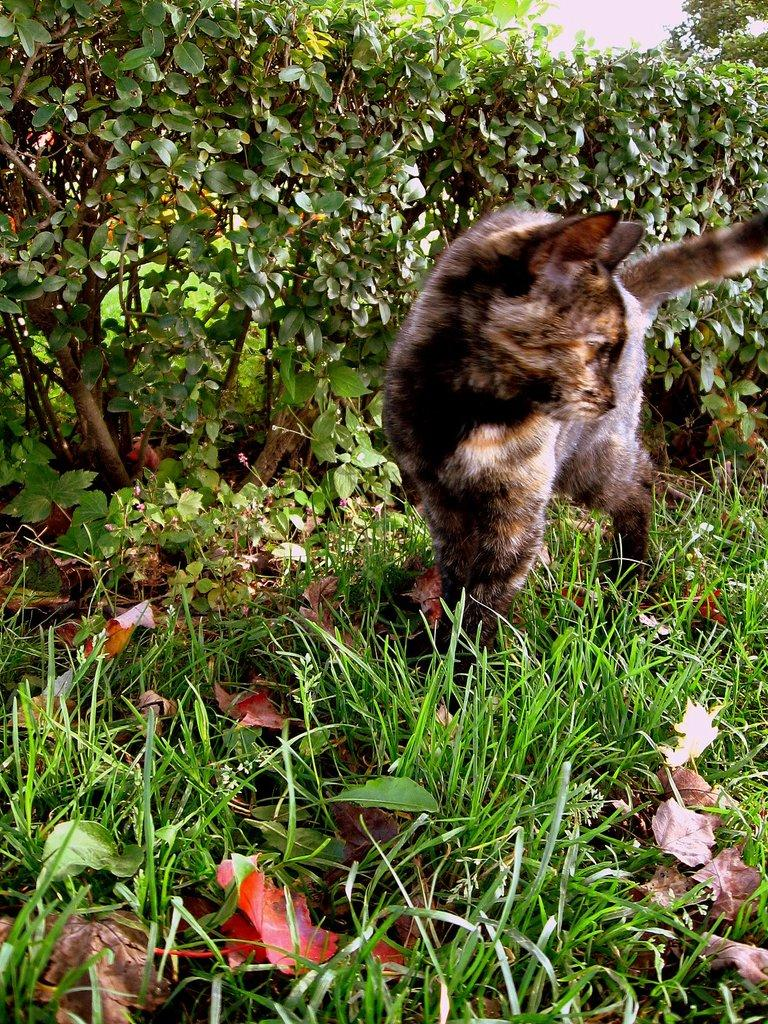Where was the picture taken? The picture was clicked outside. What can be seen in the foreground of the image? There is green grass in the foreground of the image. What is the main subject in the center of the image? There is an animal in the center of the image. What can be seen in the background of the image? There are plants visible in the background of the image. What type of baseball equipment can be seen in the image? There is no baseball equipment present in the image. Is the animal in the image being held in a jail? There is no jail or any indication of confinement in the image; the animal is freely visible in the center of the image. 